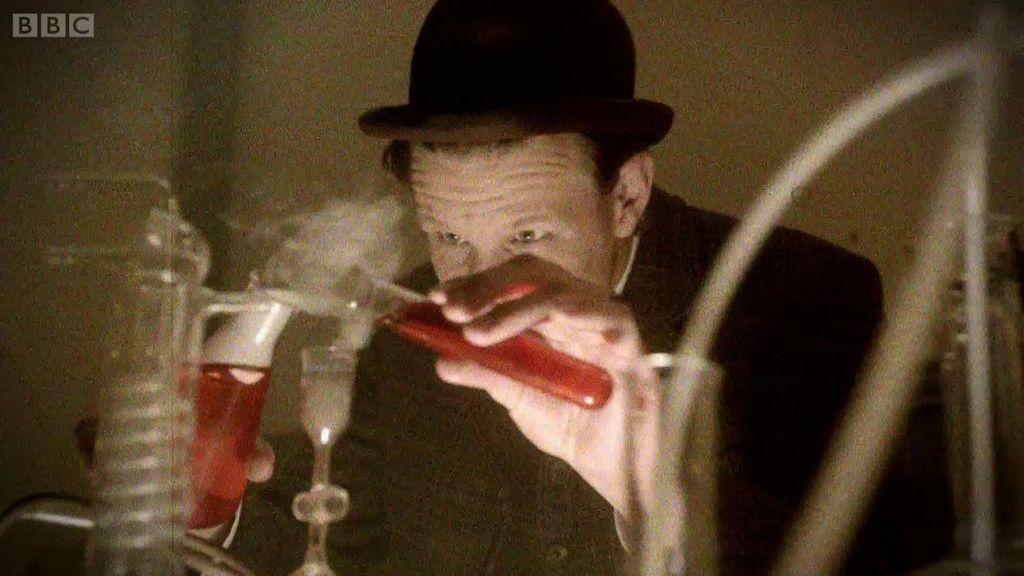How would you summarize this image in a sentence or two? In this image I can see a person holding a glass test tube. He is wearing black coat and cap. In front I can see a jar and chemical apparatus. 